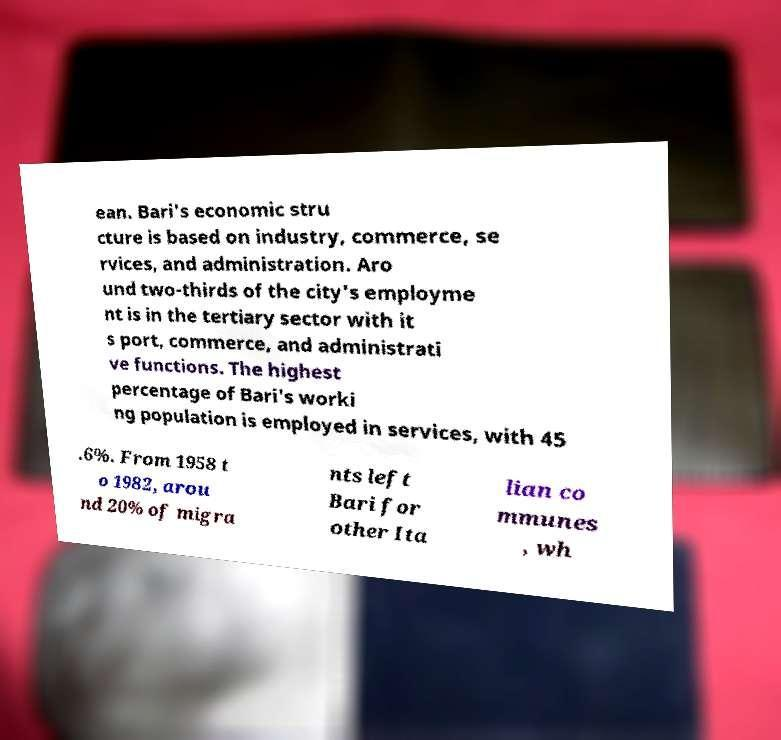Could you assist in decoding the text presented in this image and type it out clearly? ean. Bari's economic stru cture is based on industry, commerce, se rvices, and administration. Aro und two-thirds of the city's employme nt is in the tertiary sector with it s port, commerce, and administrati ve functions. The highest percentage of Bari's worki ng population is employed in services, with 45 .6%. From 1958 t o 1982, arou nd 20% of migra nts left Bari for other Ita lian co mmunes , wh 